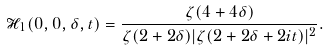<formula> <loc_0><loc_0><loc_500><loc_500>\mathcal { H } _ { 1 } ( 0 , 0 , \delta , t ) = \frac { \zeta ( 4 + 4 \delta ) } { \zeta ( 2 + 2 \delta ) | \zeta ( 2 + 2 \delta + 2 i t ) | ^ { 2 } } .</formula> 